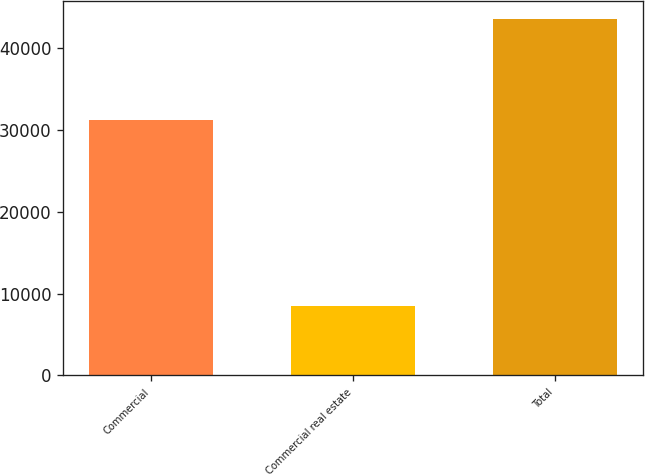<chart> <loc_0><loc_0><loc_500><loc_500><bar_chart><fcel>Commercial<fcel>Commercial real estate<fcel>Total<nl><fcel>31276<fcel>8450<fcel>43606<nl></chart> 